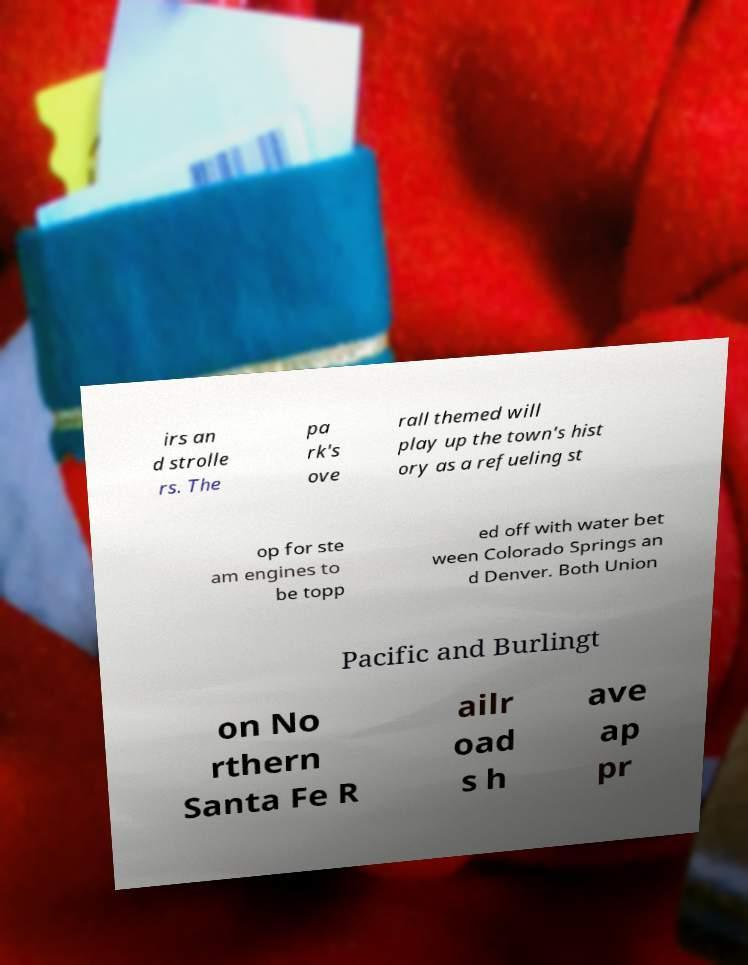Please read and relay the text visible in this image. What does it say? irs an d strolle rs. The pa rk's ove rall themed will play up the town's hist ory as a refueling st op for ste am engines to be topp ed off with water bet ween Colorado Springs an d Denver. Both Union Pacific and Burlingt on No rthern Santa Fe R ailr oad s h ave ap pr 